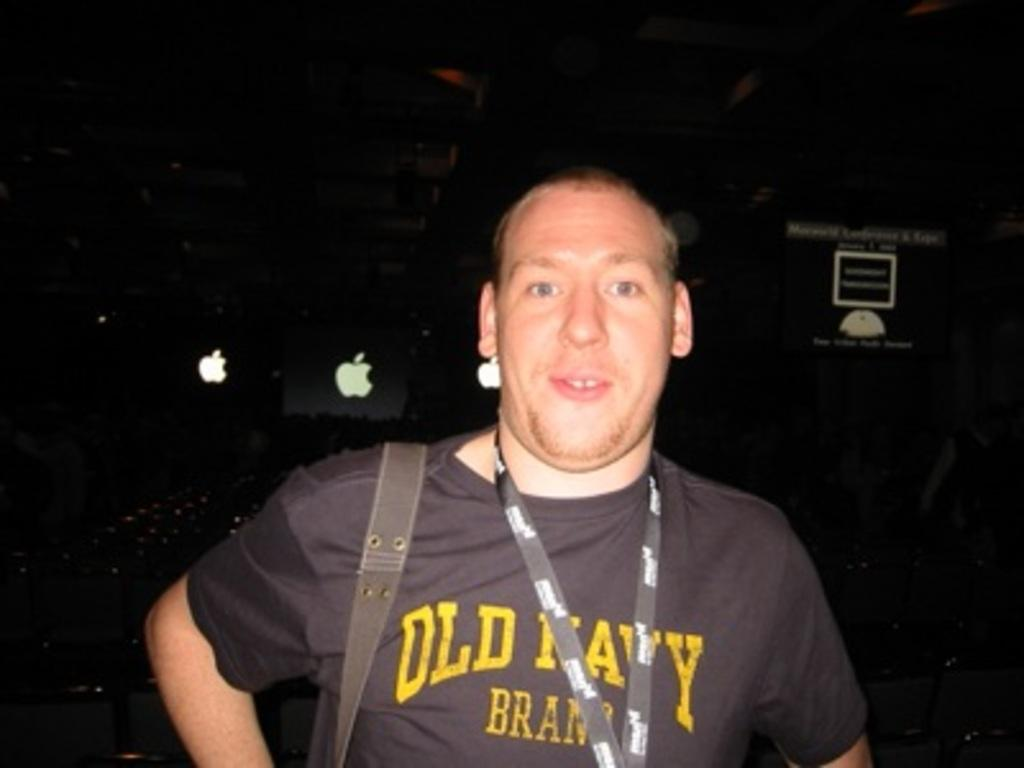What is the main subject in the foreground of the image? There is a person in the foreground of the image. What can be seen on the person's body? The person is wearing an ID card. What is the person carrying in the image? The person is carrying a bag. What can be seen in the background of the image? There is a banner with text and other objects visible in the background of the image. What type of animal is gripping the person's brain in the image? There is no animal or brain present in the image; it only features a person in the foreground and a banner with text in the background. 